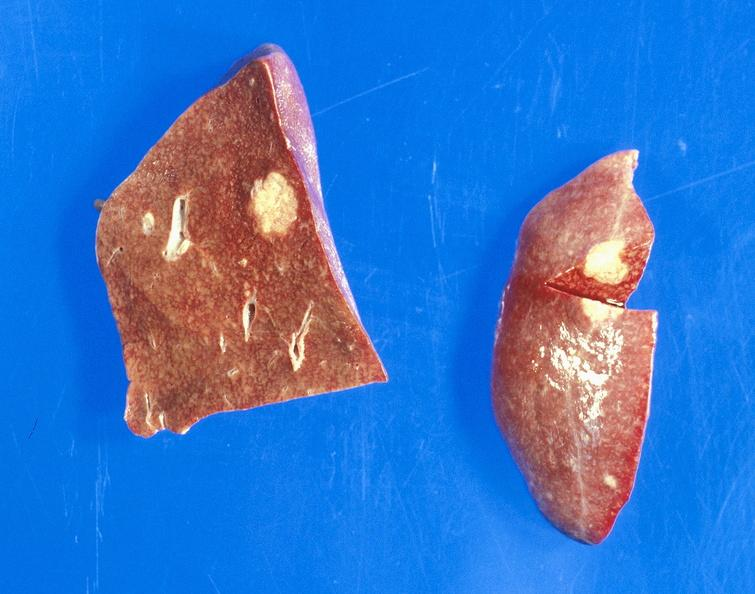s postoperative cardiac surgery present?
Answer the question using a single word or phrase. No 